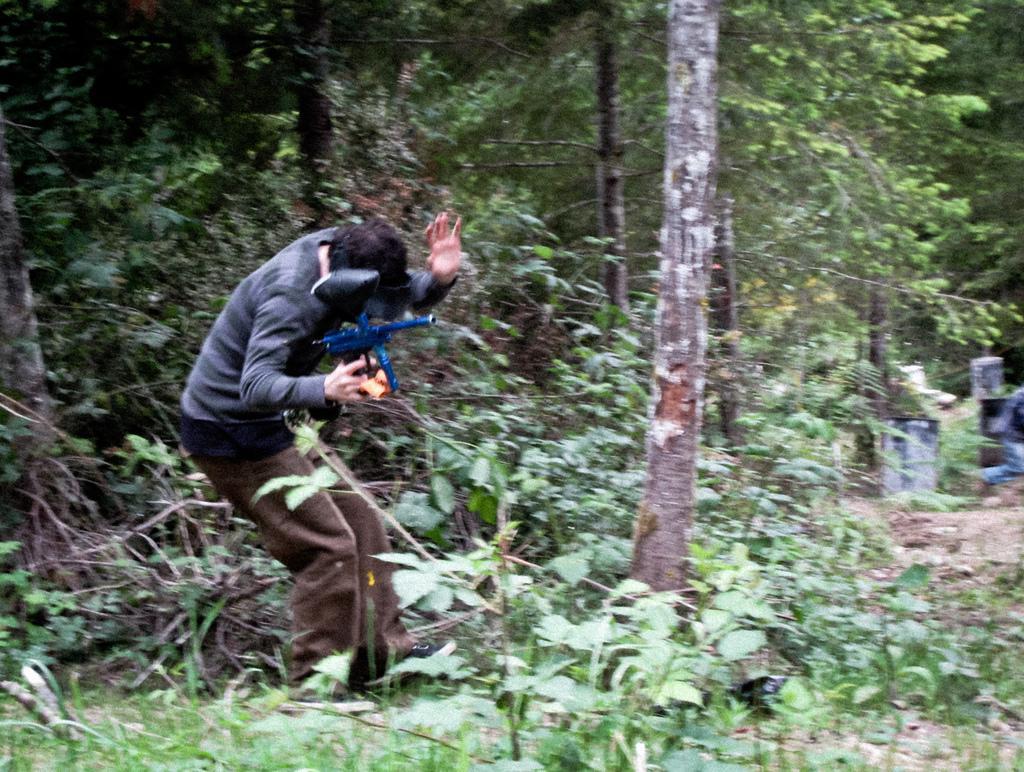Describe this image in one or two sentences. In this image on the left side there is one person who is holding something, and there are some trees, plants and grass. And on the left side there is another person, and some objects. 